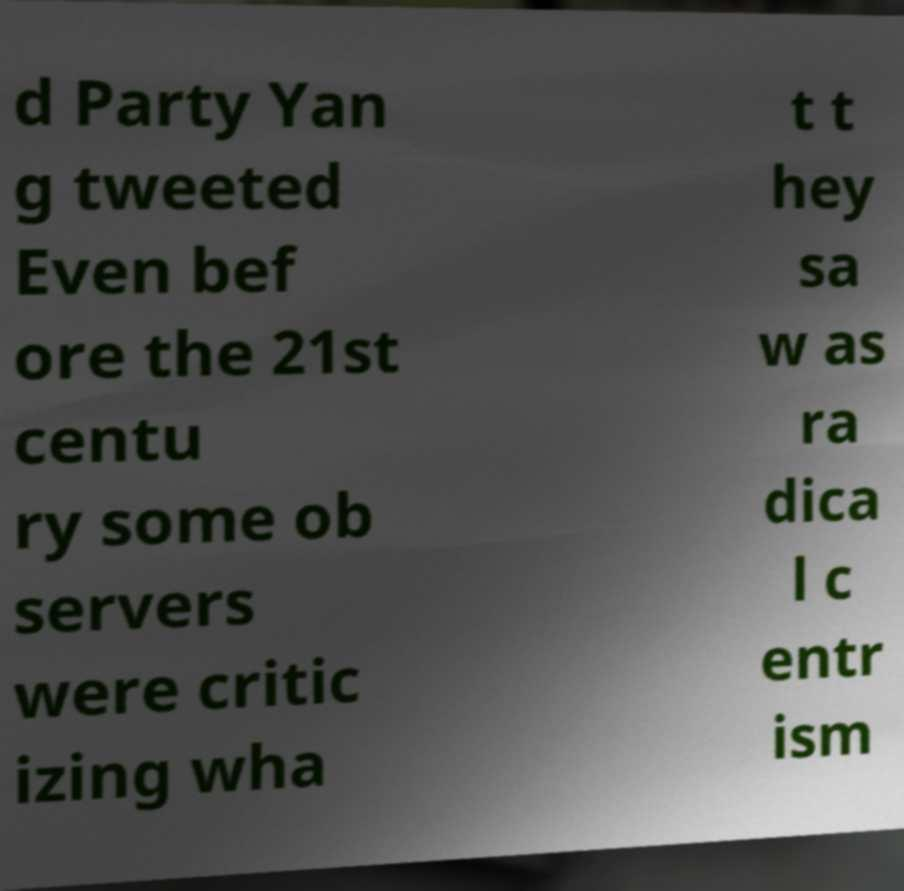Could you extract and type out the text from this image? d Party Yan g tweeted Even bef ore the 21st centu ry some ob servers were critic izing wha t t hey sa w as ra dica l c entr ism 